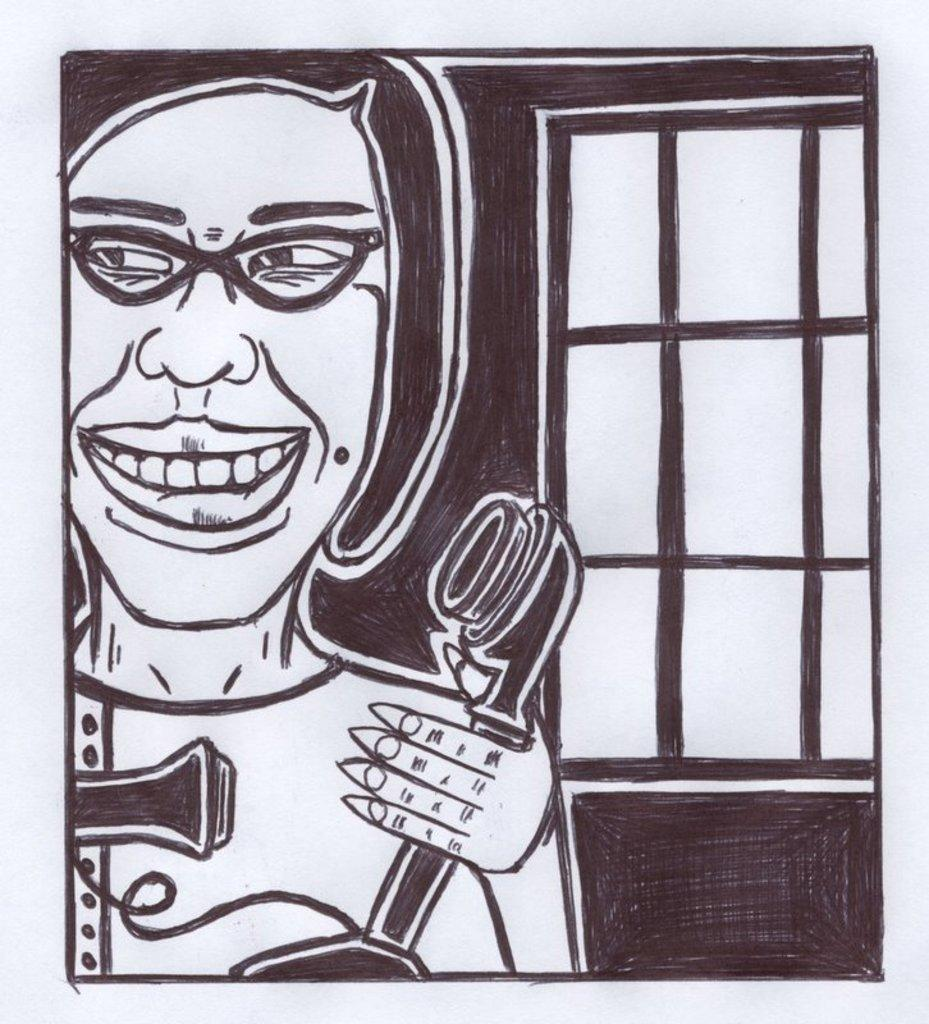What is the main subject of the sketch? The sketch contains a person. What is the person holding in the sketch? The person is holding a telephone. Is there any architectural feature depicted in the sketch? Yes, there is a window in the sketch. What type of quince can be seen in the sketch? There is no quince present in the sketch; it features a person holding a telephone and a window. Who is the representative in the sketch? There is no representative mentioned or depicted in the sketch; it only contains a person holding a telephone and a window. 